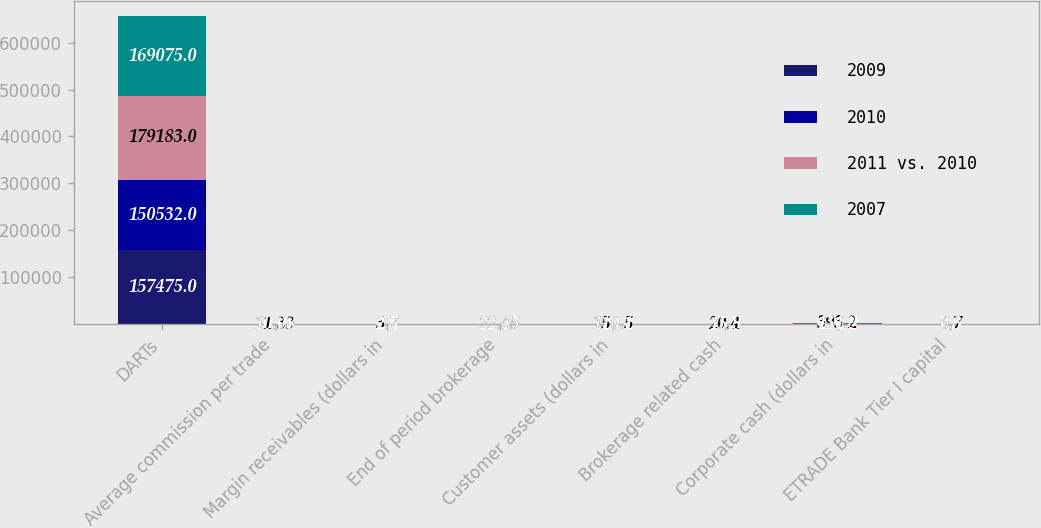Convert chart to OTSL. <chart><loc_0><loc_0><loc_500><loc_500><stacked_bar_chart><ecel><fcel>DARTs<fcel>Average commission per trade<fcel>Margin receivables (dollars in<fcel>End of period brokerage<fcel>Customer assets (dollars in<fcel>Brokerage related cash<fcel>Corporate cash (dollars in<fcel>ETRADE Bank Tier I capital<nl><fcel>2009<fcel>157475<fcel>11.01<fcel>4.8<fcel>22.45<fcel>172.4<fcel>27.7<fcel>484.4<fcel>7.8<nl><fcel>2010<fcel>150532<fcel>11.21<fcel>5.1<fcel>22.45<fcel>176.2<fcel>24.5<fcel>470.5<fcel>7.3<nl><fcel>2011 vs. 2010<fcel>179183<fcel>11.33<fcel>3.7<fcel>22.45<fcel>150.5<fcel>20.4<fcel>393.2<fcel>6.7<nl><fcel>2007<fcel>169075<fcel>10.98<fcel>2.7<fcel>22.45<fcel>110.1<fcel>15.8<fcel>434.9<fcel>6.3<nl></chart> 